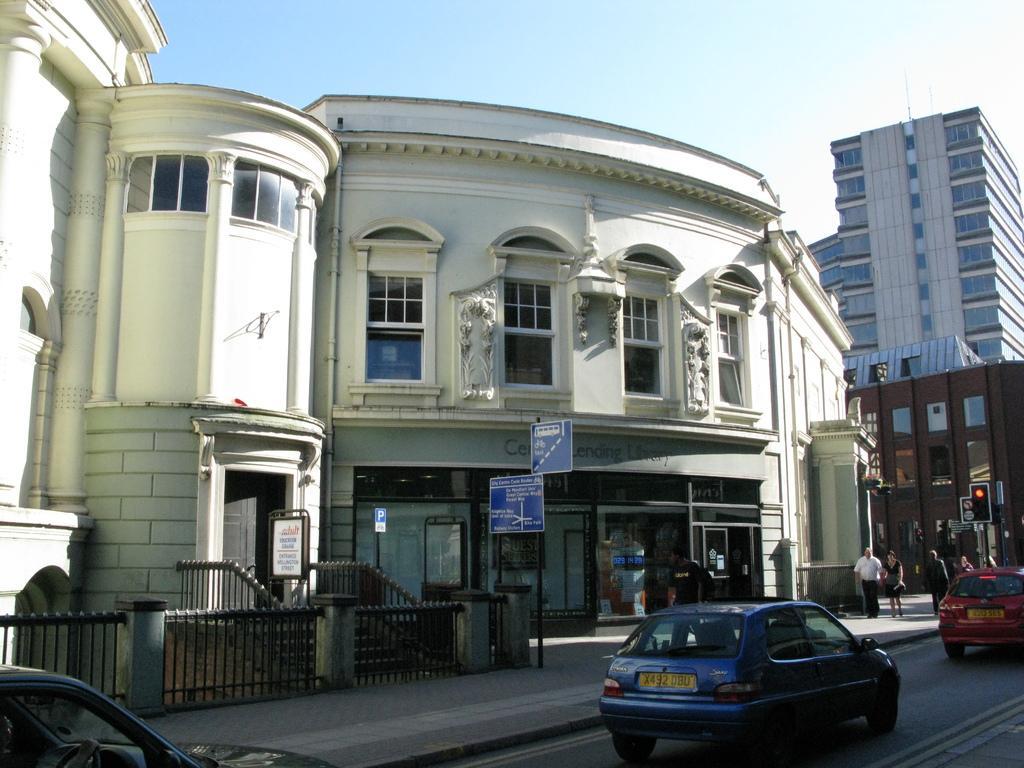Describe this image in one or two sentences. In the picture I can see the buildings and glass windows. I can see the metal fence and there are cautious board poles on the side of the road. There are a few people walking on the side of the road. In the foreground I can see the cars on the road. There is a traffic signal pole on the side of the road and it is on the right side. The sky is cloudy. 